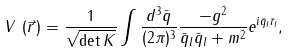Convert formula to latex. <formula><loc_0><loc_0><loc_500><loc_500>V \, \left ( \vec { r } \, \right ) = \frac { 1 } { \sqrt { \det K } } \int \frac { d ^ { 3 } \bar { q } } { ( 2 \pi ) ^ { 3 } } \frac { - g ^ { 2 } } { \bar { q } _ { l } \bar { q } _ { l } + m ^ { 2 } } e ^ { i \bar { q } _ { l } \bar { r } _ { l } } ,</formula> 